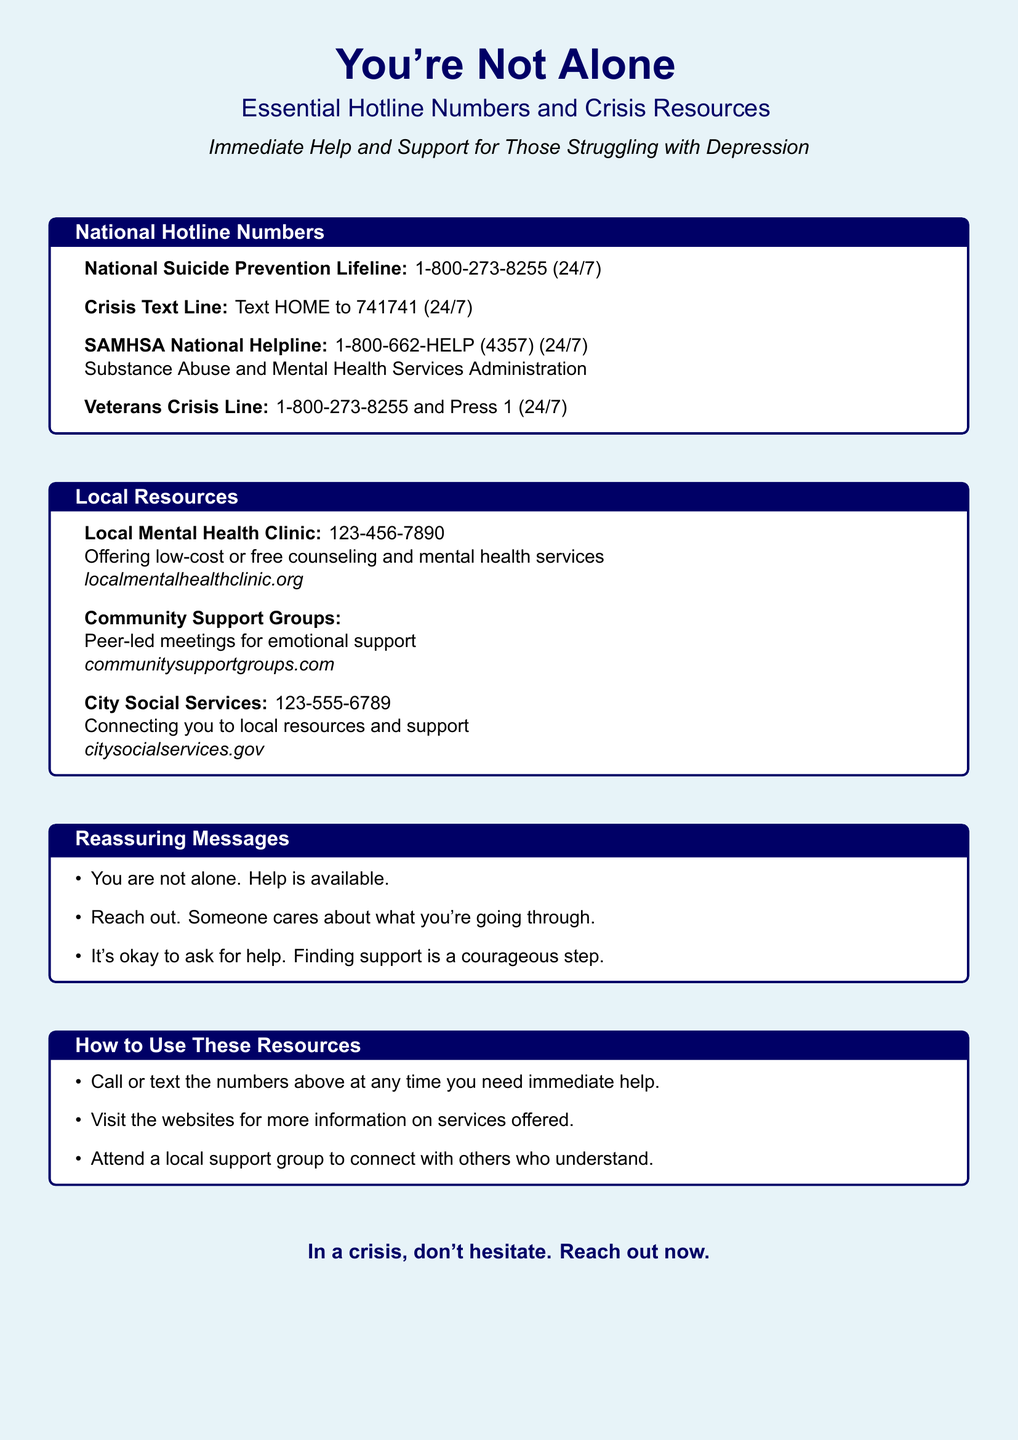What is the contact number for the National Suicide Prevention Lifeline? The document provides the contact number for the National Suicide Prevention Lifeline as 1-800-273-8255.
Answer: 1-800-273-8255 What service does the Crisis Text Line provide? According to the document, the Crisis Text Line offers support via text by sending "HOME" to 741741.
Answer: Text HOME to 741741 What is the website for the Local Mental Health Clinic? The document mentions the website for the Local Mental Health Clinic as localmentalhealthclinic.org.
Answer: localmentalhealthclinic.org What type of support do Community Support Groups offer? The document states that Community Support Groups provide peer-led meetings for emotional support.
Answer: Emotional support What message reassures individuals they are not alone? The document includes the message "You are not alone. Help is available." to reassure individuals.
Answer: You are not alone. Help is available What is one way to use the resources listed in the poster? The document advises to call or text the numbers above at any time for immediate help.
Answer: Call or text the numbers What is the main theme of the poster? The document emphasizes that individuals struggling with depression are not alone and offers various resources for help.
Answer: You're Not Alone What organization connects you to local resources and support? The City Social Services connects individuals to local resources and support as stated in the document.
Answer: City Social Services 